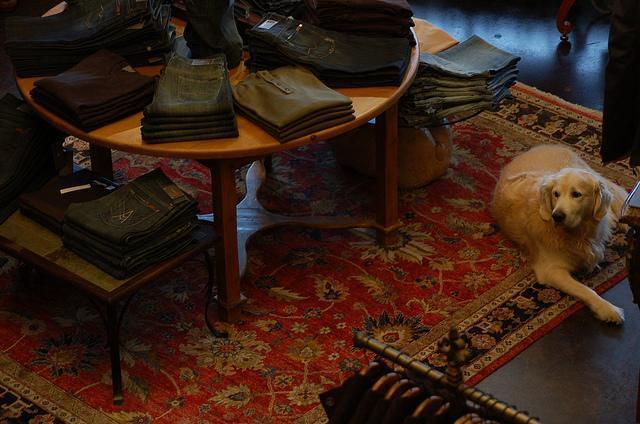How many dogs are in the picture?
Give a very brief answer. 1. 